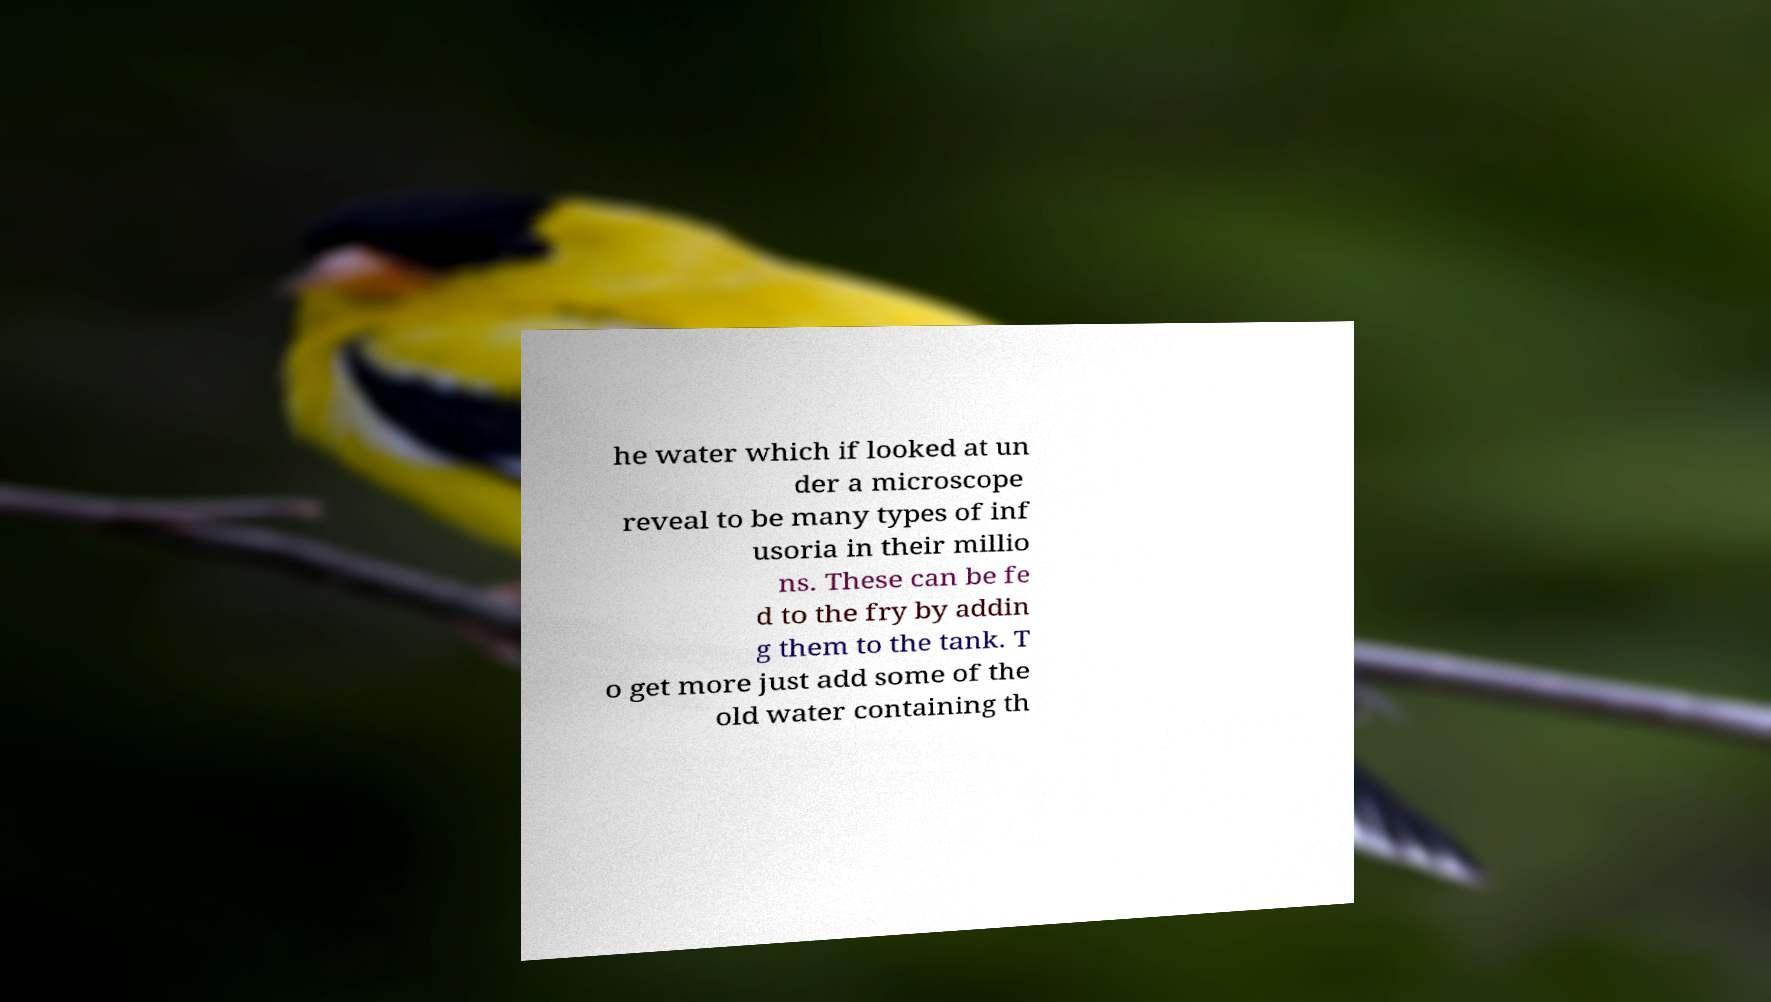Could you assist in decoding the text presented in this image and type it out clearly? he water which if looked at un der a microscope reveal to be many types of inf usoria in their millio ns. These can be fe d to the fry by addin g them to the tank. T o get more just add some of the old water containing th 